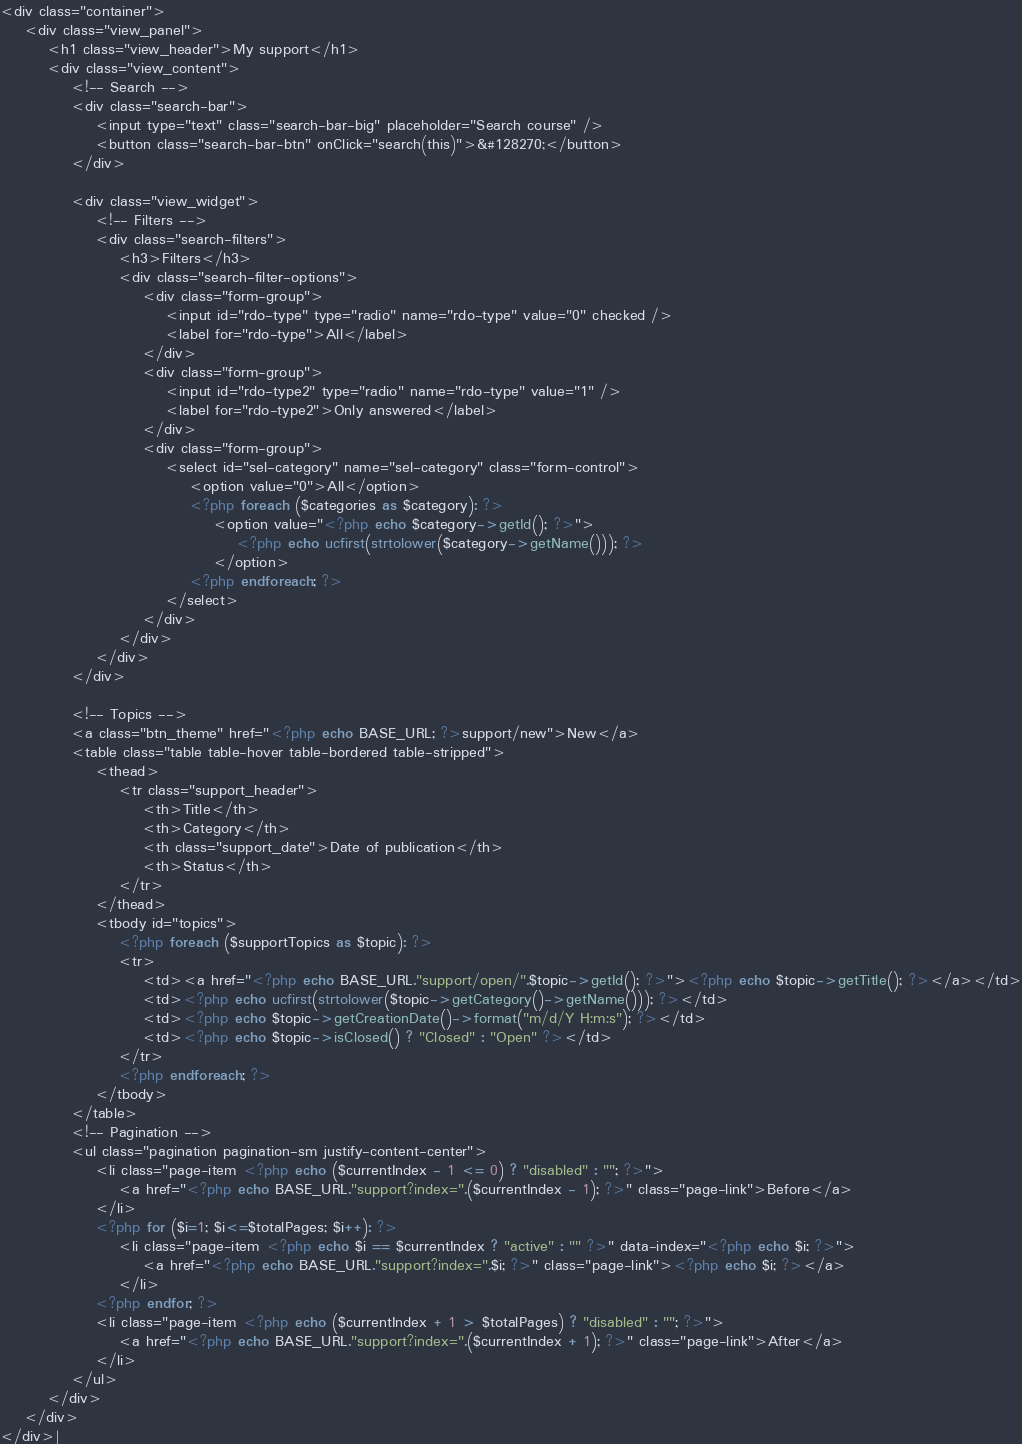<code> <loc_0><loc_0><loc_500><loc_500><_PHP_><div class="container">
	<div class="view_panel">
    	<h1 class="view_header">My support</h1>
		<div class="view_content">
        	<!-- Search -->
        	<div class="search-bar">
    			<input type="text" class="search-bar-big" placeholder="Search course" />
    			<button class="search-bar-btn" onClick="search(this)">&#128270;</button>
    		</div>
    		
			<div class="view_widget">
			    <!-- Filters -->
				<div class="search-filters">
    				<h3>Filters</h3>
    				<div class="search-filter-options">
    					<div class="form-group">
        					<input id="rdo-type" type="radio" name="rdo-type" value="0" checked />
        					<label for="rdo-type">All</label>
    					</div>
    					<div class="form-group">
        					<input id="rdo-type2" type="radio" name="rdo-type" value="1" />
        					<label for="rdo-type2">Only answered</label>
    					</div>
    					<div class="form-group">
        					<select id="sel-category" name="sel-category" class="form-control">
        						<option value="0">All</option>
        						<?php foreach ($categories as $category): ?>
        							<option value="<?php echo $category->getId(); ?>">
        								<?php echo ucfirst(strtolower($category->getName())); ?>
    								</option>
        						<?php endforeach; ?>
        					</select>
    					</div>
    				</div>
				</div>
			</div>
        	
        	<!-- Topics -->
        	<a class="btn_theme" href="<?php echo BASE_URL; ?>support/new">New</a>
            <table class="table table-hover table-bordered table-stripped">
            	<thead>
            		<tr class="support_header">
            			<th>Title</th>
            			<th>Category</th>
            			<th class="support_date">Date of publication</th>
            			<th>Status</th>
            		</tr>
            	</thead>
            	<tbody id="topics">
            		<?php foreach ($supportTopics as $topic): ?>
            		<tr>
            			<td><a href="<?php echo BASE_URL."support/open/".$topic->getId(); ?>"><?php echo $topic->getTitle(); ?></a></td>
            			<td><?php echo ucfirst(strtolower($topic->getCategory()->getName())); ?></td>
            			<td><?php echo $topic->getCreationDate()->format("m/d/Y H:m:s"); ?></td>
            			<td><?php echo $topic->isClosed() ? "Closed" : "Open" ?></td>
            		</tr>
            		<?php endforeach; ?>
            	</tbody>
            </table>
            <!-- Pagination -->
			<ul class="pagination pagination-sm justify-content-center">
				<li class="page-item <?php echo ($currentIndex - 1 <= 0) ? "disabled" : ""; ?>">
					<a href="<?php echo BASE_URL."support?index=".($currentIndex - 1); ?>" class="page-link">Before</a>
				</li>
				<?php for ($i=1; $i<=$totalPages; $i++): ?>
    				<li class="page-item <?php echo $i == $currentIndex ? "active" : "" ?>" data-index="<?php echo $i; ?>">
    					<a href="<?php echo BASE_URL."support?index=".$i; ?>" class="page-link"><?php echo $i; ?></a>
					</li>
				<?php endfor; ?>
				<li class="page-item <?php echo ($currentIndex + 1 > $totalPages) ? "disabled" : ""; ?>">
					<a href="<?php echo BASE_URL."support?index=".($currentIndex + 1); ?>" class="page-link">After</a>
				</li>
			</ul>
        </div>
    </div>
</div>|</code> 